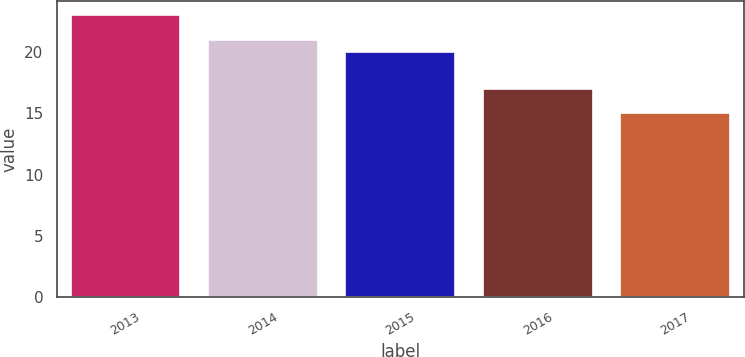Convert chart to OTSL. <chart><loc_0><loc_0><loc_500><loc_500><bar_chart><fcel>2013<fcel>2014<fcel>2015<fcel>2016<fcel>2017<nl><fcel>23<fcel>21<fcel>20<fcel>17<fcel>15<nl></chart> 